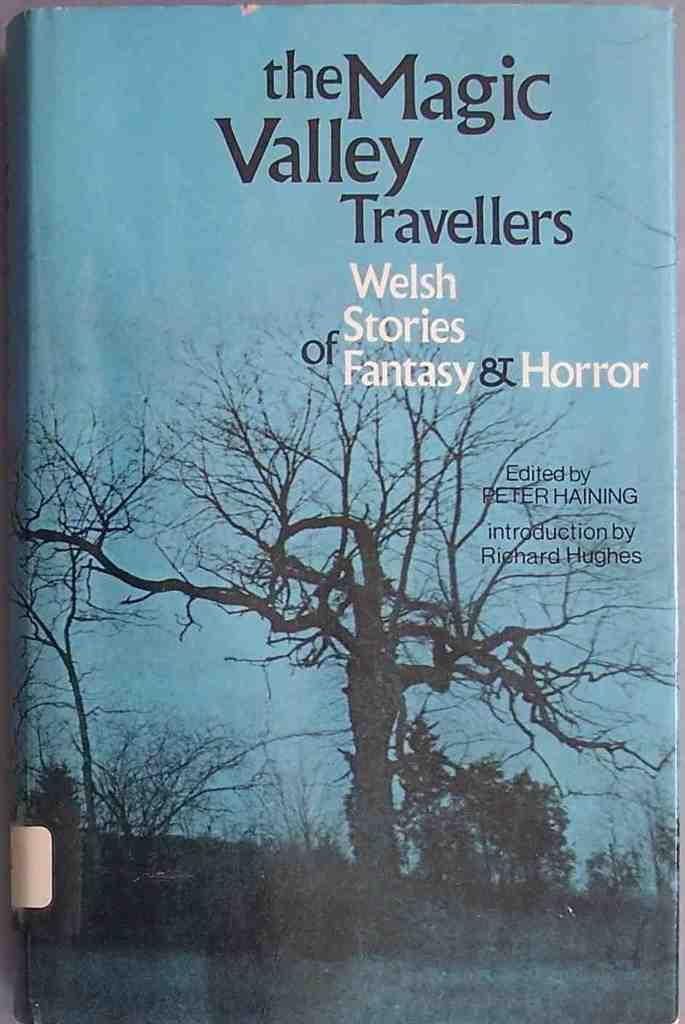<image>
Summarize the visual content of the image. A novel supplies a collection of Welsh stories of fantasy and horror. 